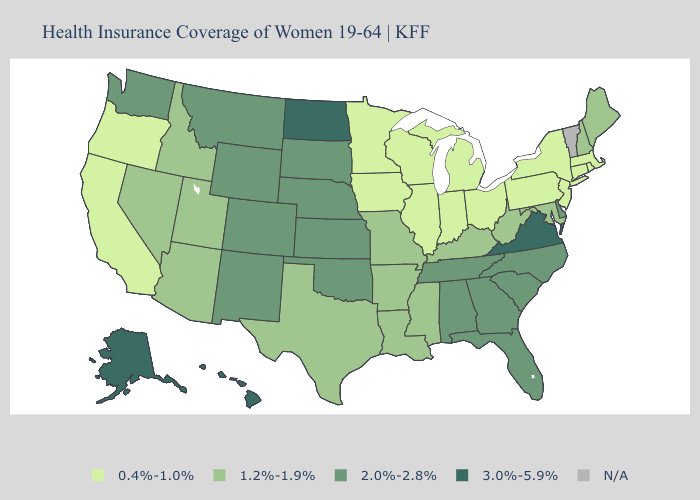Name the states that have a value in the range 3.0%-5.9%?
Keep it brief. Alaska, Hawaii, North Dakota, Virginia. Among the states that border Oklahoma , does Arkansas have the lowest value?
Write a very short answer. Yes. What is the lowest value in the Northeast?
Concise answer only. 0.4%-1.0%. What is the value of Nebraska?
Write a very short answer. 2.0%-2.8%. Name the states that have a value in the range 0.4%-1.0%?
Be succinct. California, Connecticut, Illinois, Indiana, Iowa, Massachusetts, Michigan, Minnesota, New Jersey, New York, Ohio, Oregon, Pennsylvania, Rhode Island, Wisconsin. Name the states that have a value in the range 3.0%-5.9%?
Keep it brief. Alaska, Hawaii, North Dakota, Virginia. What is the lowest value in states that border South Dakota?
Concise answer only. 0.4%-1.0%. What is the value of Vermont?
Be succinct. N/A. What is the value of Oregon?
Concise answer only. 0.4%-1.0%. What is the value of South Dakota?
Keep it brief. 2.0%-2.8%. What is the value of Iowa?
Answer briefly. 0.4%-1.0%. Among the states that border Illinois , does Indiana have the highest value?
Quick response, please. No. What is the value of West Virginia?
Short answer required. 1.2%-1.9%. 